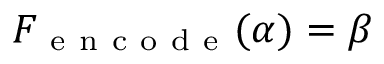Convert formula to latex. <formula><loc_0><loc_0><loc_500><loc_500>F _ { e n c o d e } ( \alpha ) = \beta</formula> 